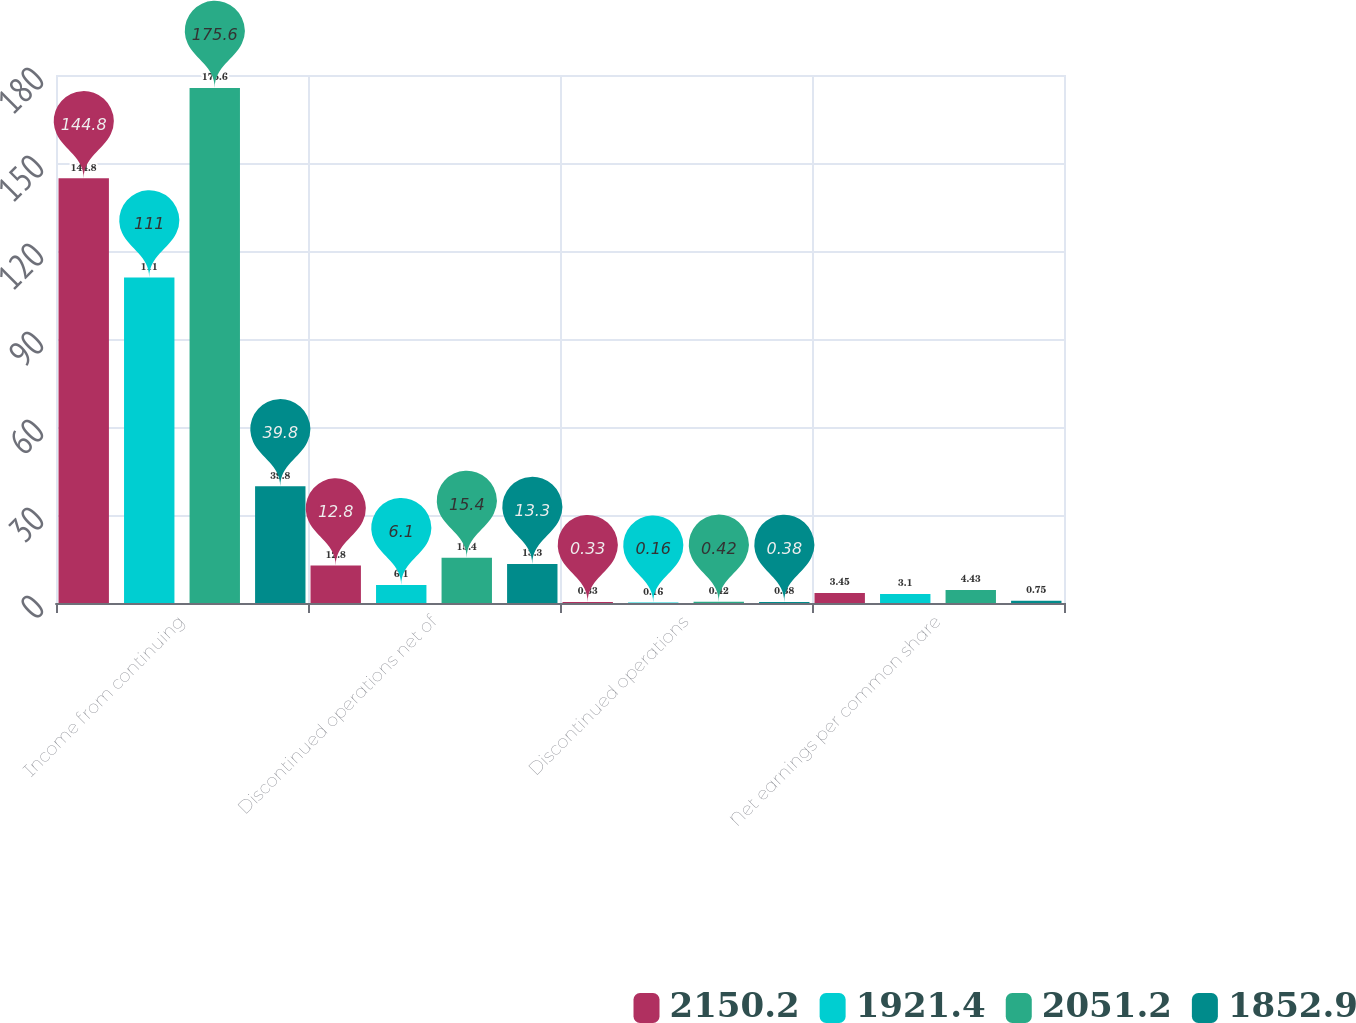Convert chart to OTSL. <chart><loc_0><loc_0><loc_500><loc_500><stacked_bar_chart><ecel><fcel>Income from continuing<fcel>Discontinued operations net of<fcel>Discontinued operations<fcel>Net earnings per common share<nl><fcel>2150.2<fcel>144.8<fcel>12.8<fcel>0.33<fcel>3.45<nl><fcel>1921.4<fcel>111<fcel>6.1<fcel>0.16<fcel>3.1<nl><fcel>2051.2<fcel>175.6<fcel>15.4<fcel>0.42<fcel>4.43<nl><fcel>1852.9<fcel>39.8<fcel>13.3<fcel>0.38<fcel>0.75<nl></chart> 